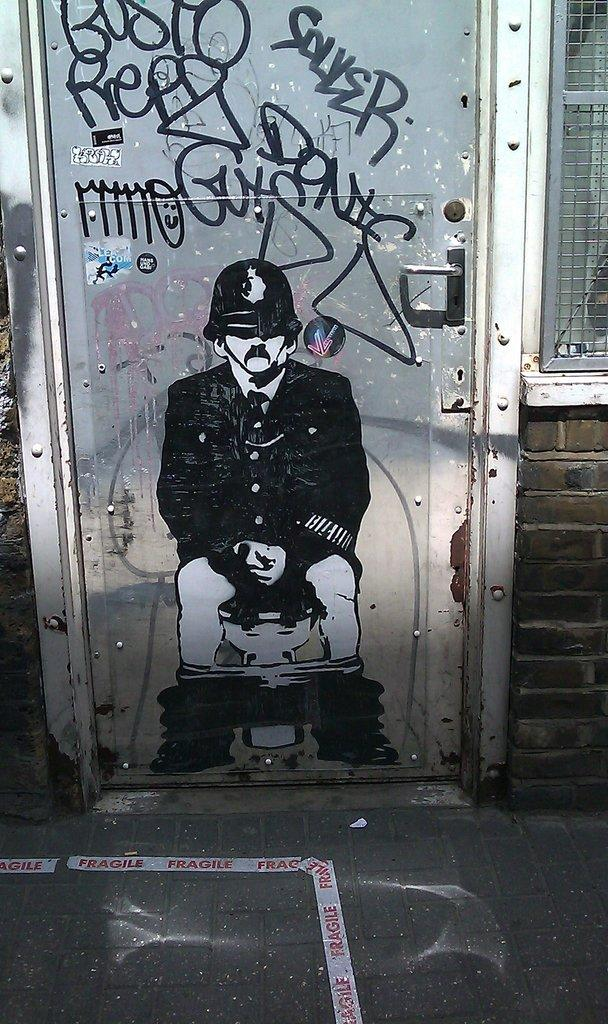What is present on the wall in the image? There is a picture of a person on the wall. What can be observed about the person in the picture? The person in the picture is wearing clothes and a helmet. What type of surface is visible beneath the wall? There is a floor visible in the image. Can you describe another feature in the image? There is a mesh in the image. What is the wall made of? The wall is made of bricks, as it is a brick wall. What type of cherry is being eaten by the man in the image? There is no man present in the image, and therefore no cherry-eating activity can be observed. 